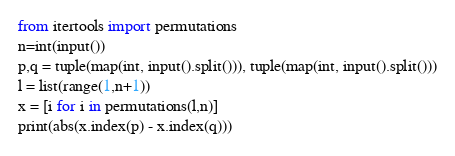Convert code to text. <code><loc_0><loc_0><loc_500><loc_500><_Python_>from itertools import permutations
n=int(input())
p,q = tuple(map(int, input().split())), tuple(map(int, input().split()))
l = list(range(1,n+1))
x = [i for i in permutations(l,n)]
print(abs(x.index(p) - x.index(q)))</code> 